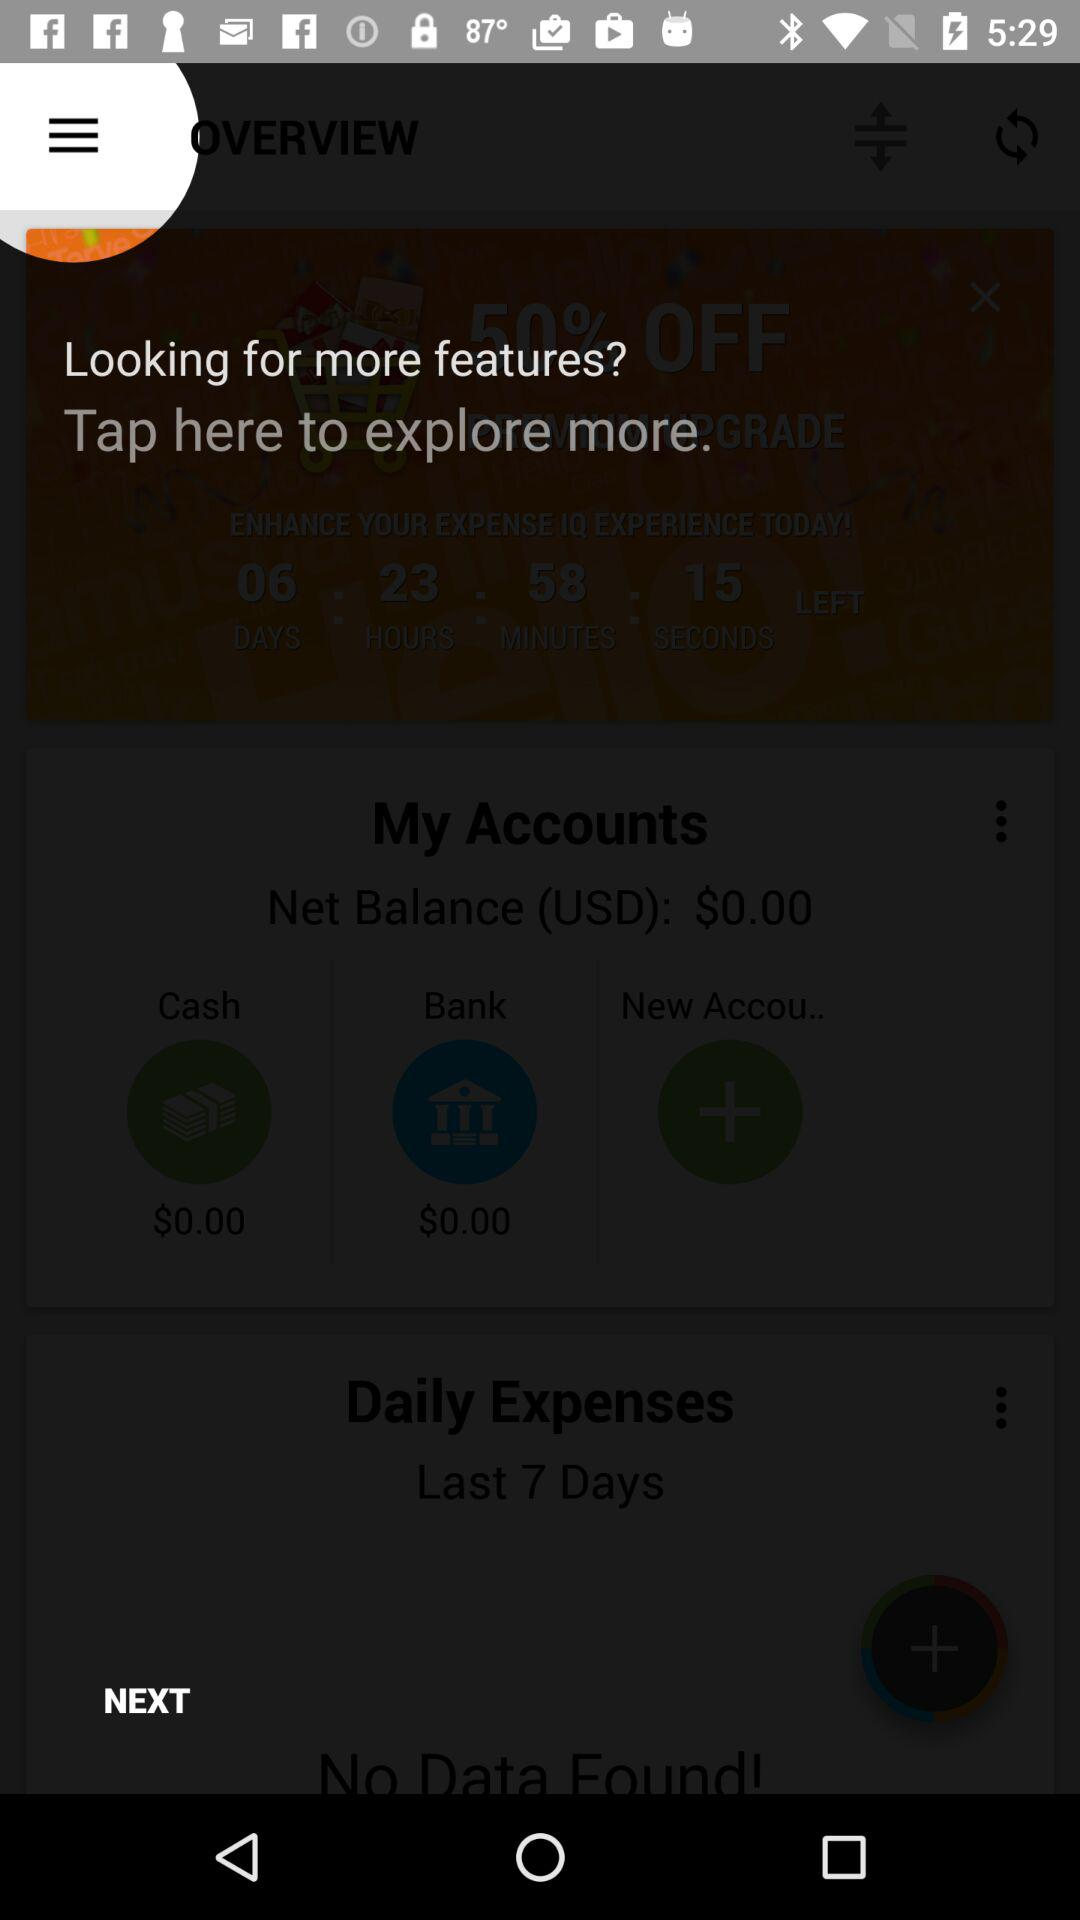What is the net bank balance? The net bank balance is $0. 